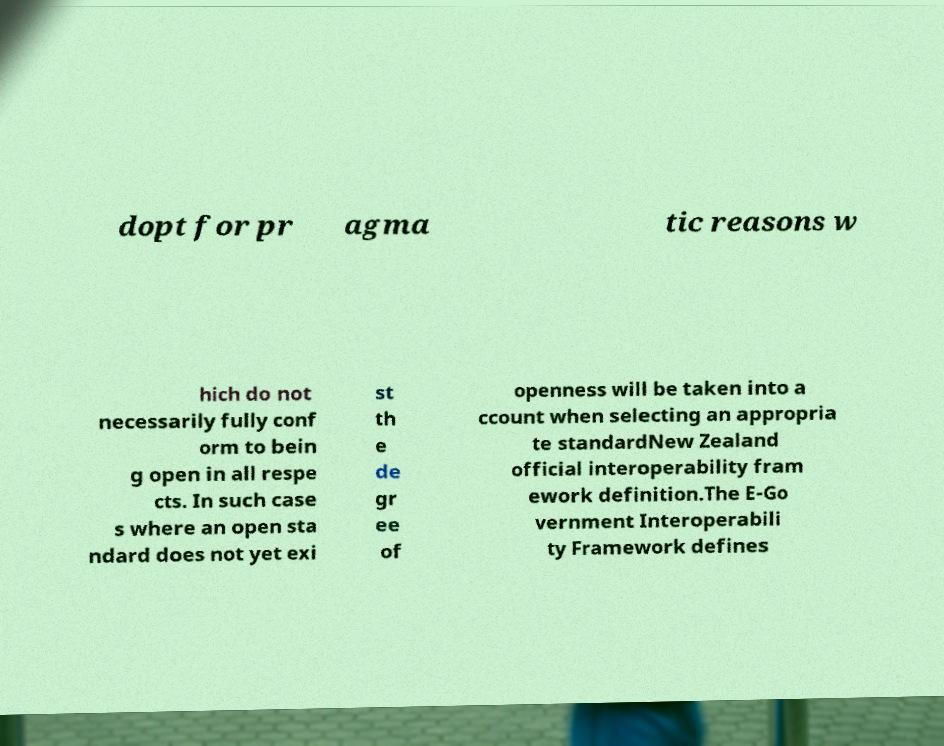I need the written content from this picture converted into text. Can you do that? dopt for pr agma tic reasons w hich do not necessarily fully conf orm to bein g open in all respe cts. In such case s where an open sta ndard does not yet exi st th e de gr ee of openness will be taken into a ccount when selecting an appropria te standardNew Zealand official interoperability fram ework definition.The E-Go vernment Interoperabili ty Framework defines 